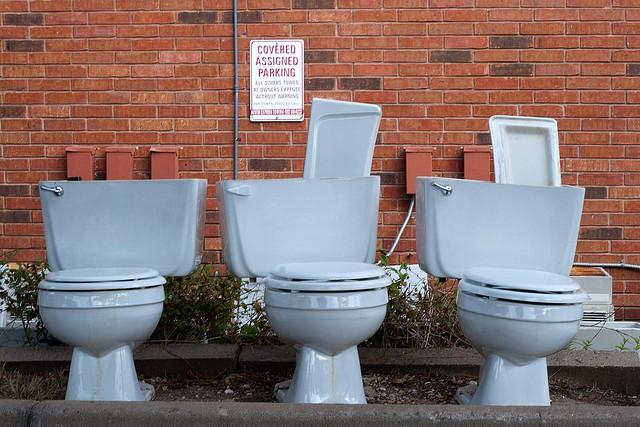How many toilet bowls are sat in this area next to the side of the street? Please explain your reasoning. three. The picture is very clear as to how many toilets there are in the photo. 